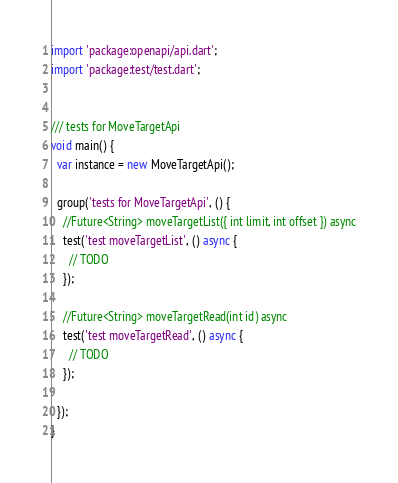<code> <loc_0><loc_0><loc_500><loc_500><_Dart_>import 'package:openapi/api.dart';
import 'package:test/test.dart';


/// tests for MoveTargetApi
void main() {
  var instance = new MoveTargetApi();

  group('tests for MoveTargetApi', () {
    //Future<String> moveTargetList({ int limit, int offset }) async
    test('test moveTargetList', () async {
      // TODO
    });

    //Future<String> moveTargetRead(int id) async
    test('test moveTargetRead', () async {
      // TODO
    });

  });
}
</code> 